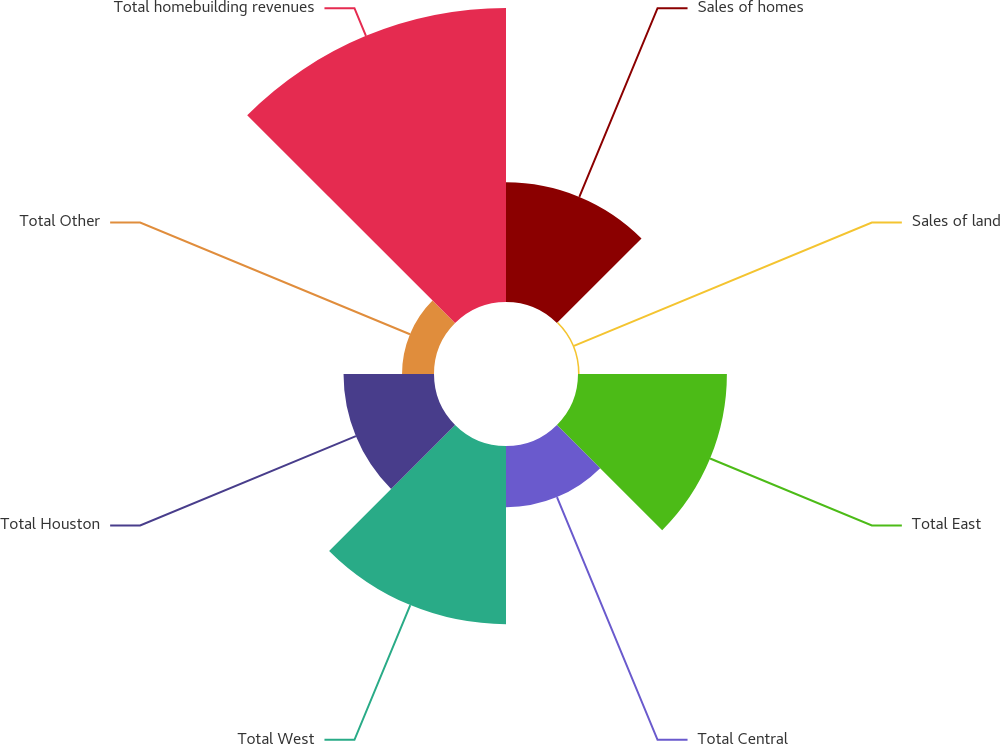<chart> <loc_0><loc_0><loc_500><loc_500><pie_chart><fcel>Sales of homes<fcel>Sales of land<fcel>Total East<fcel>Total Central<fcel>Total West<fcel>Total Houston<fcel>Total Other<fcel>Total homebuilding revenues<nl><fcel>12.92%<fcel>0.17%<fcel>16.08%<fcel>6.61%<fcel>19.24%<fcel>9.77%<fcel>3.45%<fcel>31.75%<nl></chart> 